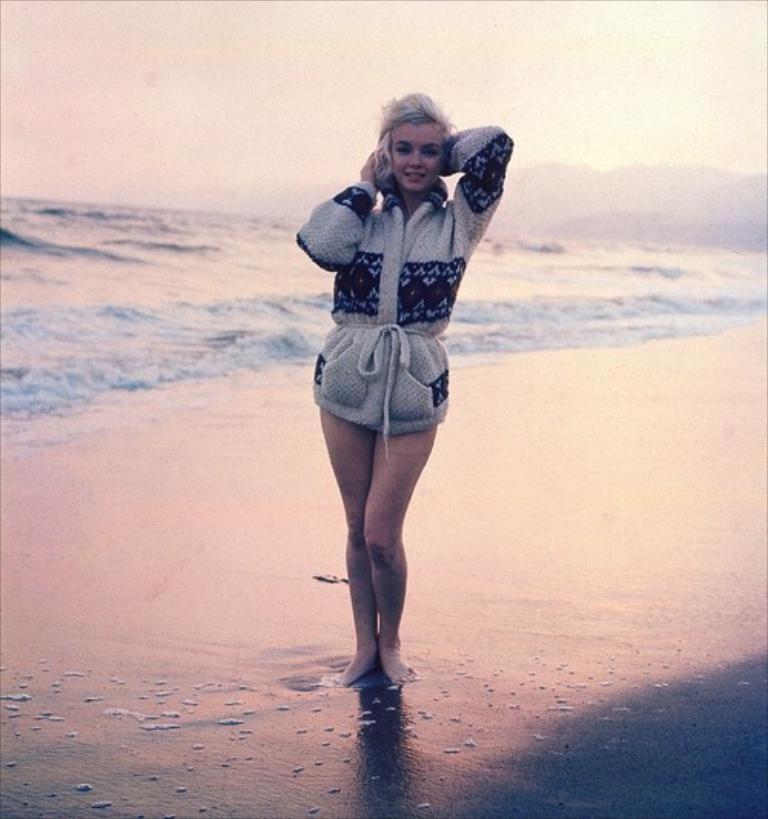How would you summarize this image in a sentence or two? As we can see in the image there is water, a girl standing in the front and there is sky. 